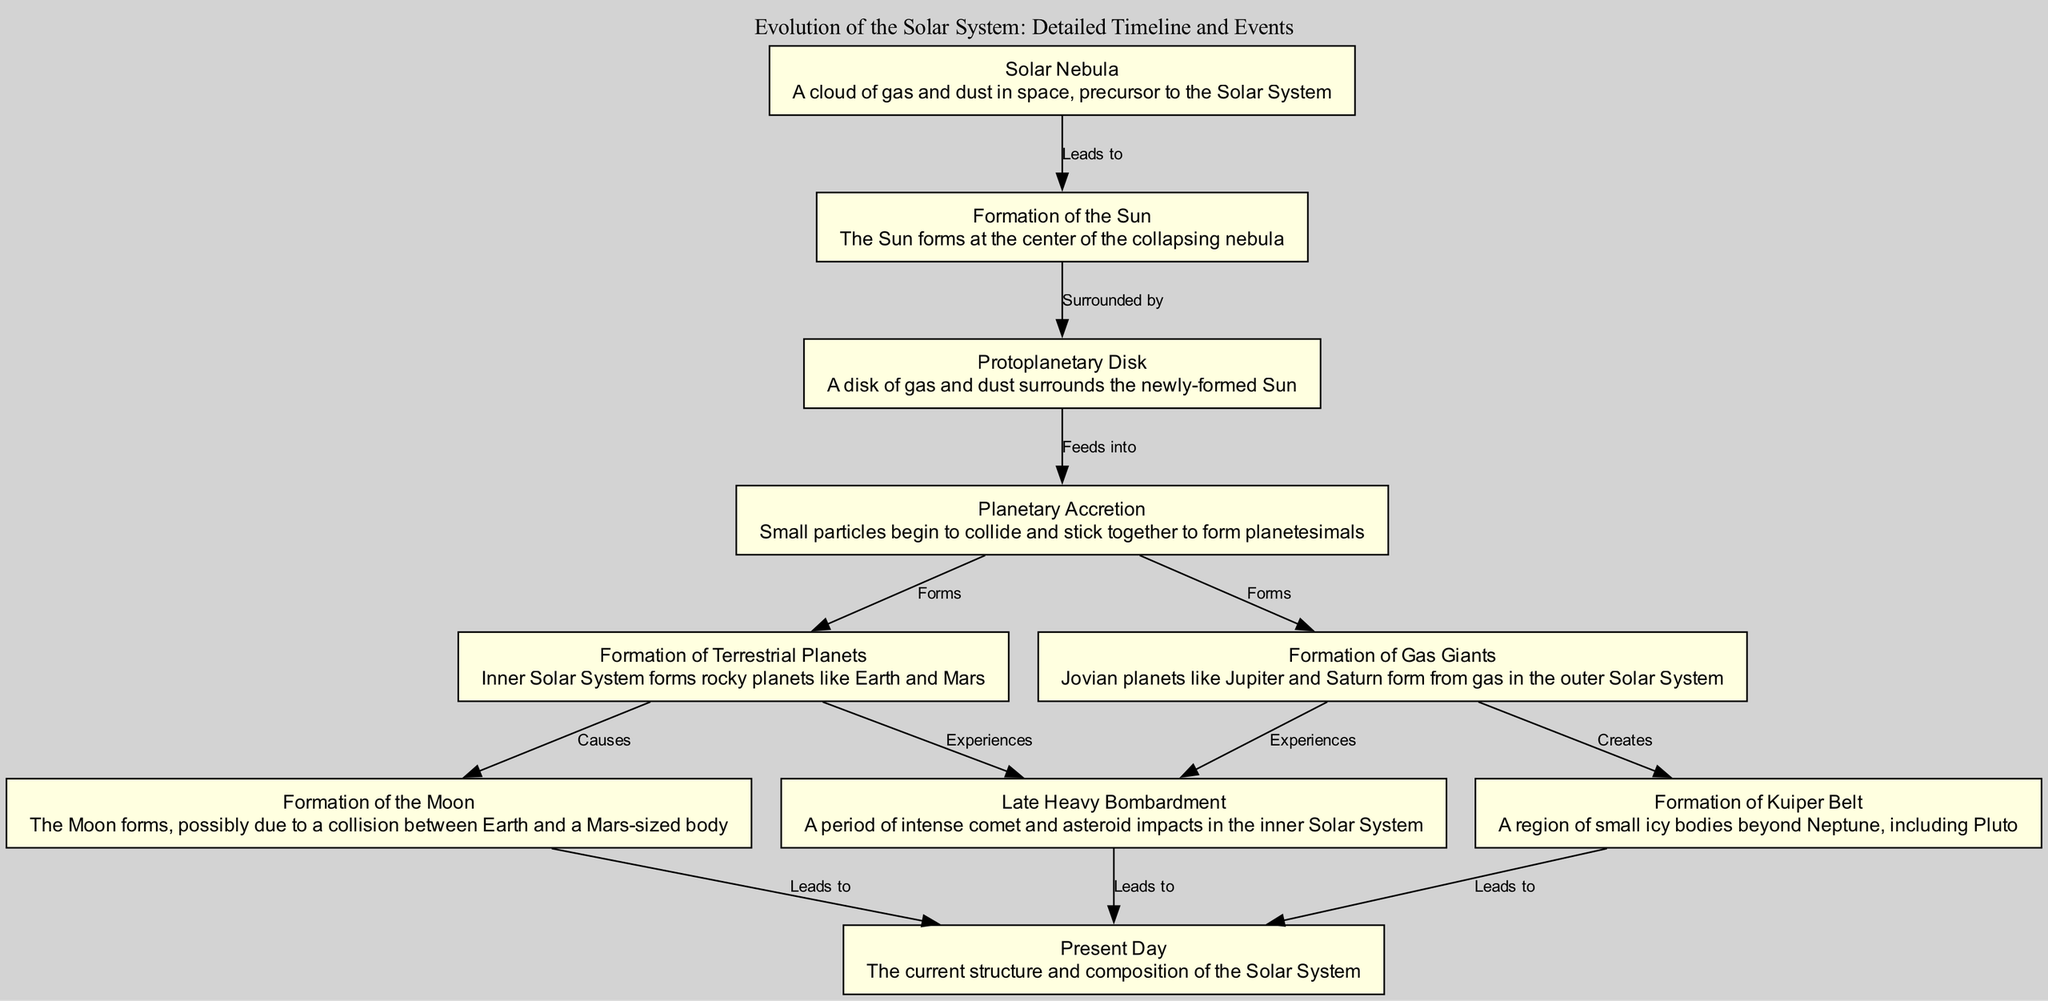What is the first event in the timeline? The diagram starts with the "Solar Nebula," which is depicted as the initial event leading to the formation of the Solar System.
Answer: Solar Nebula How many nodes are there in the diagram? The diagram consists of 10 nodes, each representing a significant event in the evolution of the Solar System.
Answer: 10 What event follows the formation of the Sun? The event that follows the "Formation of the Sun" is the "Protoplanetary Disk," which is shown as surrounding the newly-formed Sun.
Answer: Protoplanetary Disk Which planets formed in the inner Solar System? The "Formation of Terrestrial Planets" event indicates that rocky planets like Earth and Mars formed in the inner Solar System, as described in the diagram.
Answer: Earth and Mars What major event is related to both the formation of gas giants and the Kuiper Belt? The "Formation of Gas Giants" leads to the "Formation of Kuiper Belt," indicating that the gas giants' formation contributed to creating this region of icy bodies.
Answer: Formation of Kuiper Belt What event is described as causing the Moon's formation? The diagram specifies that the "Formation of the Moon" occurred possibly due to the collision between Earth and a Mars-sized body, making this the cause of the Moon's formation.
Answer: Collision between Earth and a Mars-sized body What leads to the current structure and composition of the Solar System? The diagram indicates that the "Late Heavy Bombardment," "Formation of the Moon," and "Formation of Kuiper Belt" events all lead to the present-day structure of the Solar System.
Answer: Late Heavy Bombardment, Formation of the Moon, Formation of Kuiper Belt How many edges are present in the diagram? The number of edges connecting the nodes in the diagram is 12, as it details the relationships between the various events.
Answer: 12 What is the last event in the timeline? The last event depicted in the diagram is "Present Day," representing the current state of the Solar System after all previous events have taken place.
Answer: Present Day 